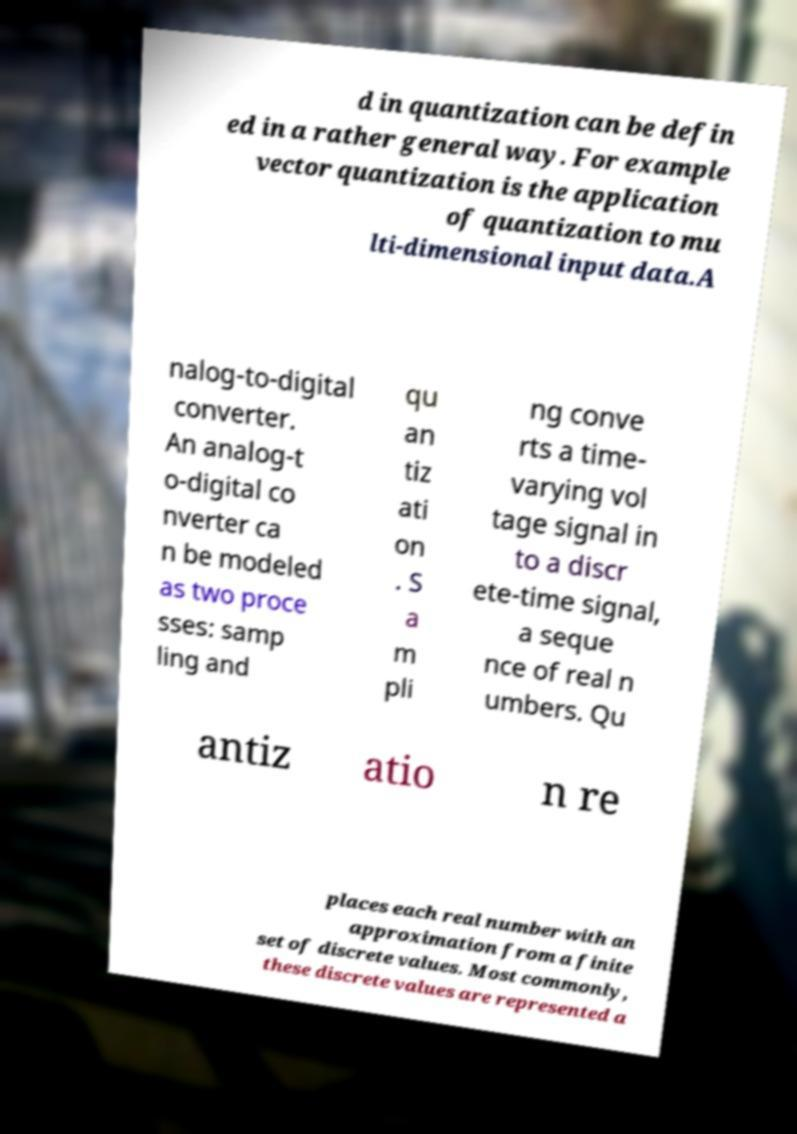Could you assist in decoding the text presented in this image and type it out clearly? d in quantization can be defin ed in a rather general way. For example vector quantization is the application of quantization to mu lti-dimensional input data.A nalog-to-digital converter. An analog-t o-digital co nverter ca n be modeled as two proce sses: samp ling and qu an tiz ati on . S a m pli ng conve rts a time- varying vol tage signal in to a discr ete-time signal, a seque nce of real n umbers. Qu antiz atio n re places each real number with an approximation from a finite set of discrete values. Most commonly, these discrete values are represented a 